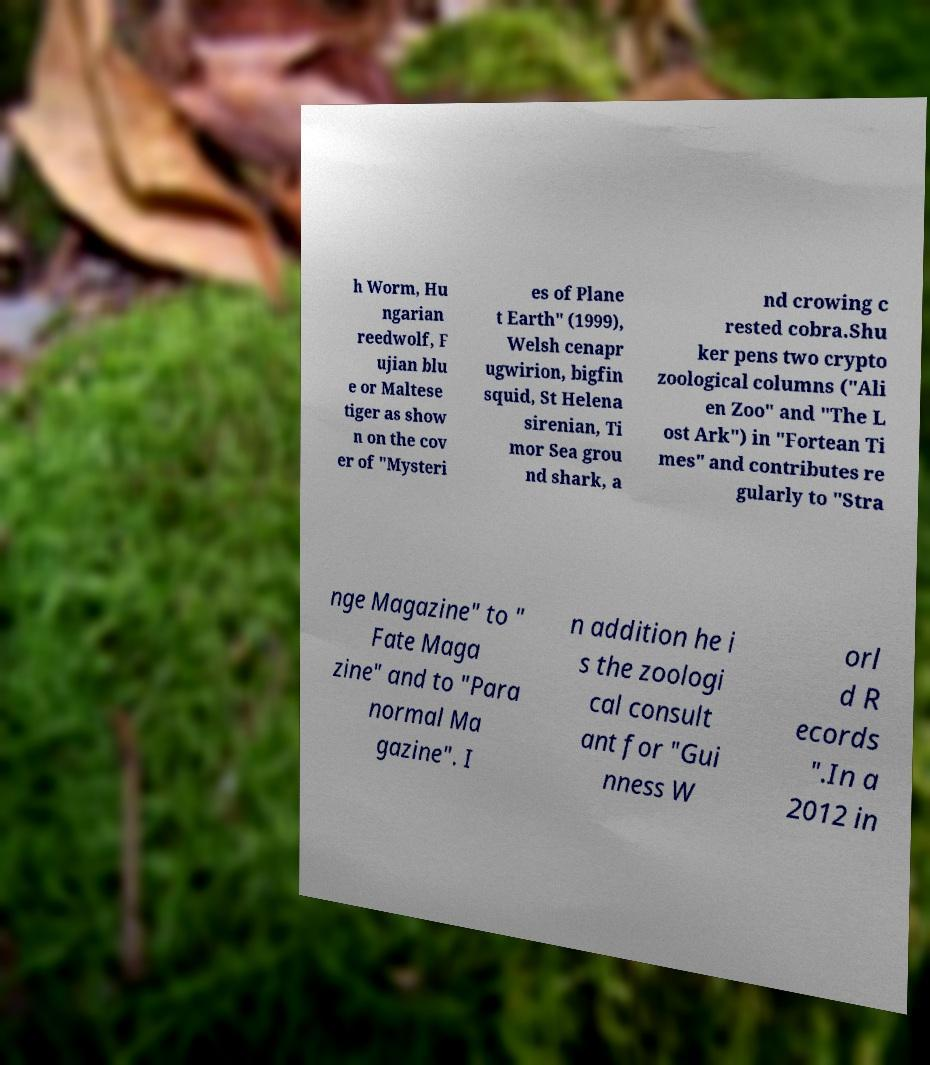There's text embedded in this image that I need extracted. Can you transcribe it verbatim? h Worm, Hu ngarian reedwolf, F ujian blu e or Maltese tiger as show n on the cov er of "Mysteri es of Plane t Earth" (1999), Welsh cenapr ugwirion, bigfin squid, St Helena sirenian, Ti mor Sea grou nd shark, a nd crowing c rested cobra.Shu ker pens two crypto zoological columns ("Ali en Zoo" and "The L ost Ark") in "Fortean Ti mes" and contributes re gularly to "Stra nge Magazine" to " Fate Maga zine" and to "Para normal Ma gazine". I n addition he i s the zoologi cal consult ant for "Gui nness W orl d R ecords ".In a 2012 in 